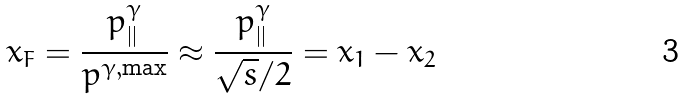<formula> <loc_0><loc_0><loc_500><loc_500>x _ { F } = \frac { p ^ { \gamma } _ { | | } } { p ^ { \gamma , \max } } \approx \frac { p ^ { \gamma } _ { | | } } { \sqrt { s } / 2 } = x _ { 1 } - x _ { 2 }</formula> 